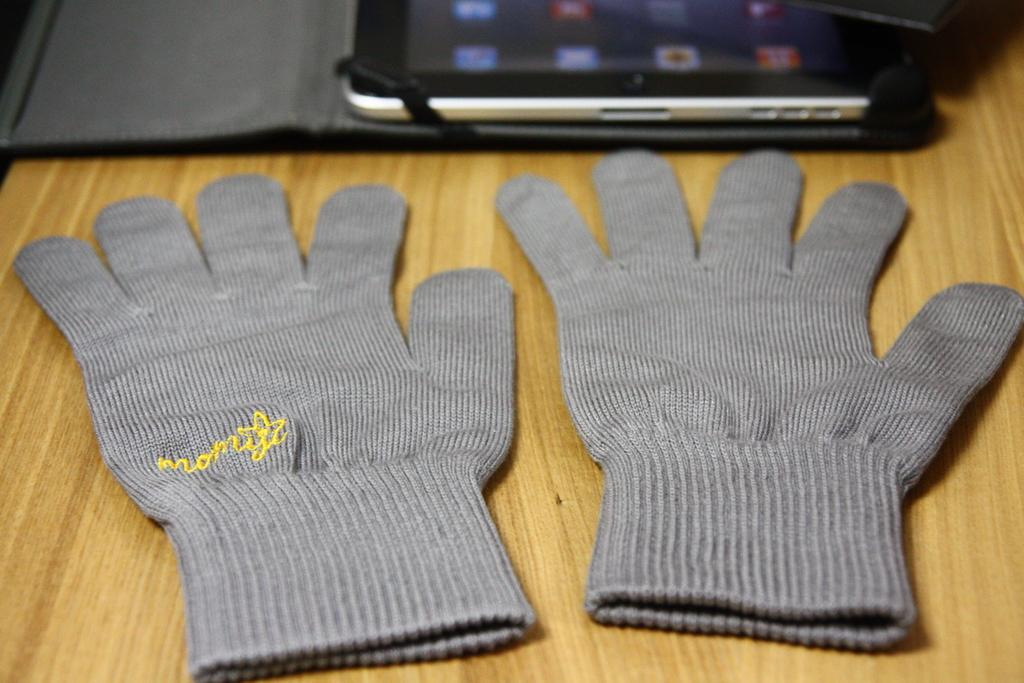What type of accessory is present in the image? There is a pair of gloves in the image. What electronic device is visible in the image? There is an iPad with a case cover in the image. On what surface are the gloves and iPad placed? Both items are on a wooden board. What type of food is being prepared on the train in the image? There is no train or food preparation visible in the image; it only features a pair of gloves and an iPad on a wooden board. 